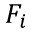<formula> <loc_0><loc_0><loc_500><loc_500>F _ { i }</formula> 